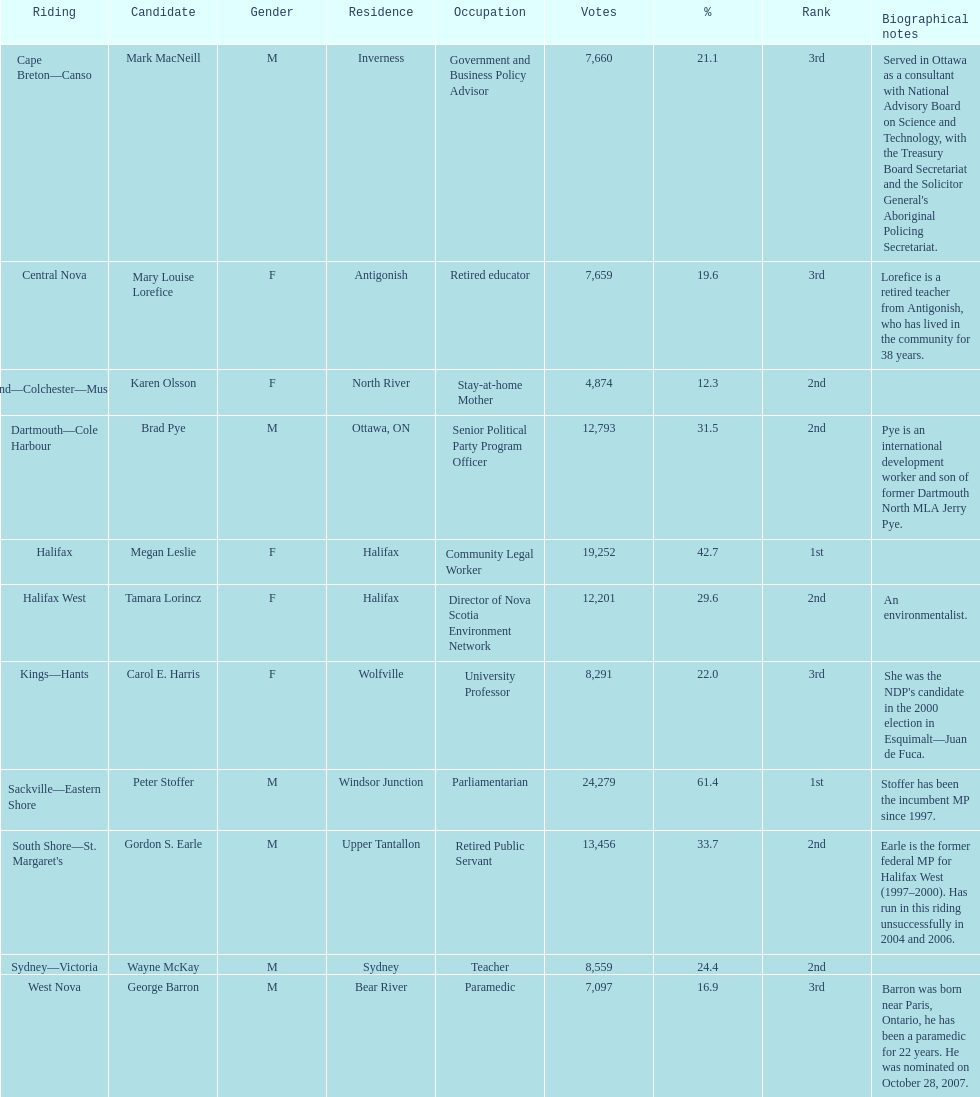What is the total of votes megan leslie secured? 19,252. 